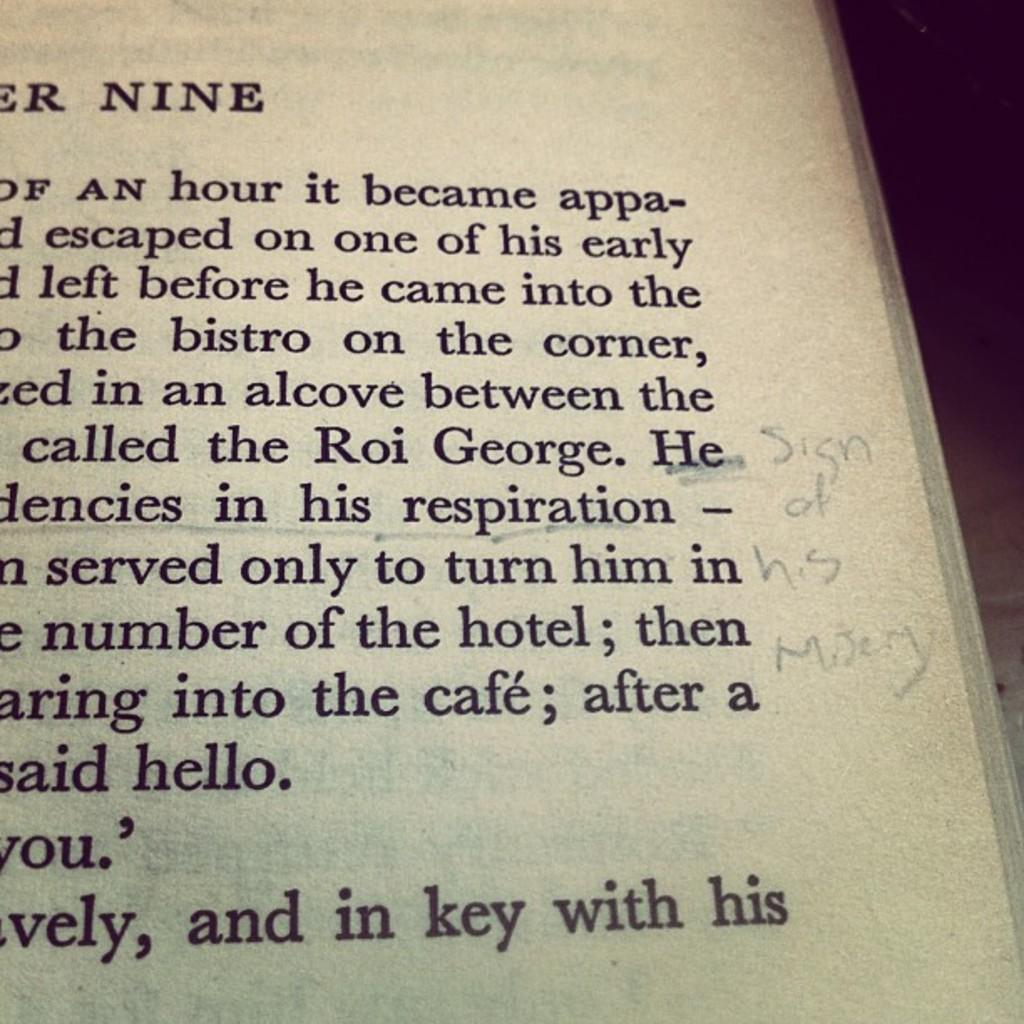<image>
Describe the image concisely. some words on pages and the number 9 at the top 